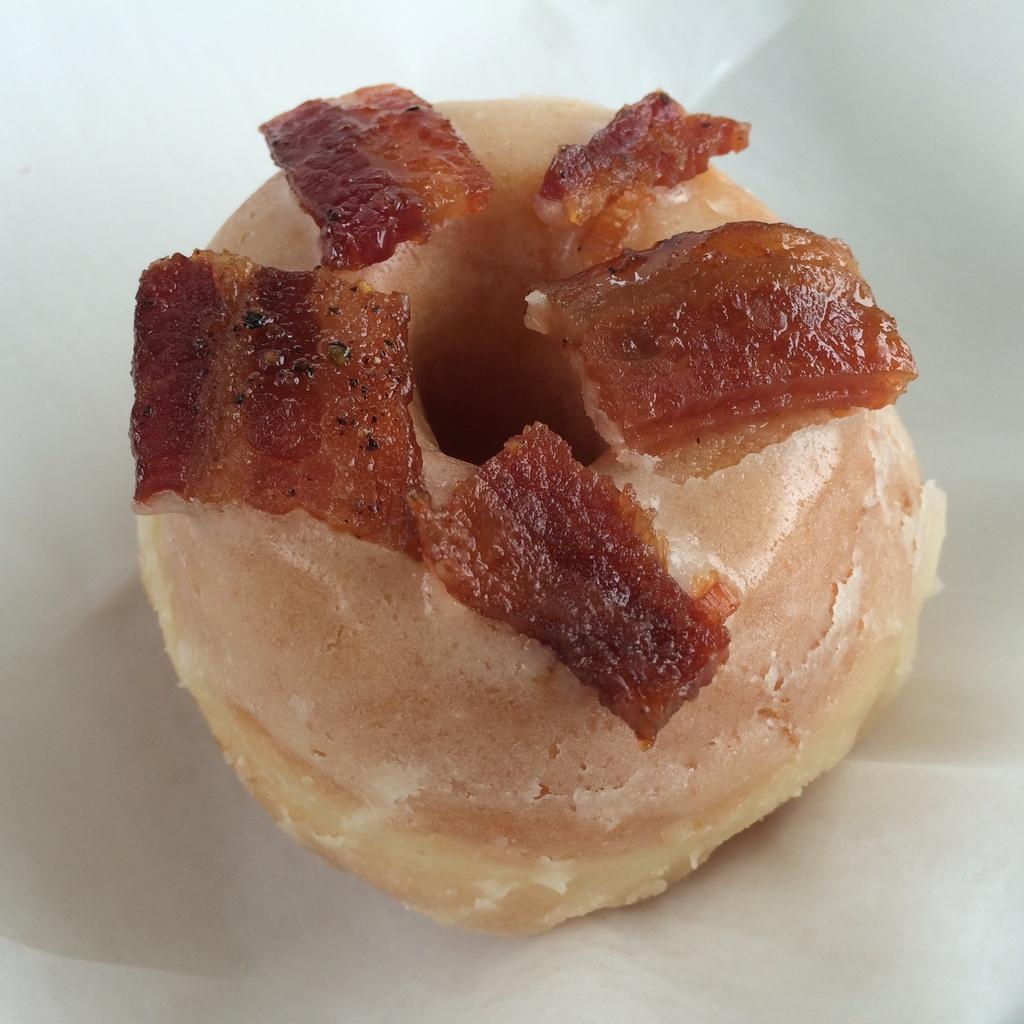What is the main subject of the image? There is a food item in the image. Can you describe the surface on which the food item is placed? The food item is on a white surface. What type of whip is being used to create the food item in the image? There is no whip present in the image, and the food item's creation method cannot be determined from the image alone. 